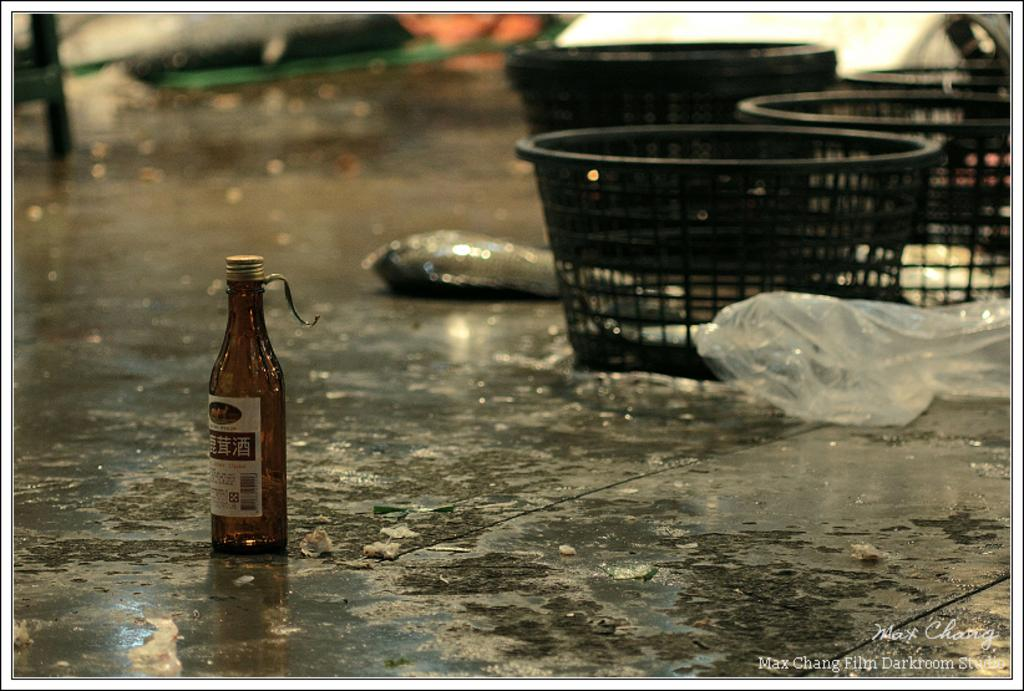What type of objects can be seen in the image? There are plastic bags and a bottle in the image. Where are the objects located? The objects are on land. What can be inferred about the weather from the background of the image? The background of the image appears to be rainy. What type of beam can be seen supporting the jar in the image? There is no beam or jar present in the image. How hot is the hot object in the image? There is no hot object present in the image. 